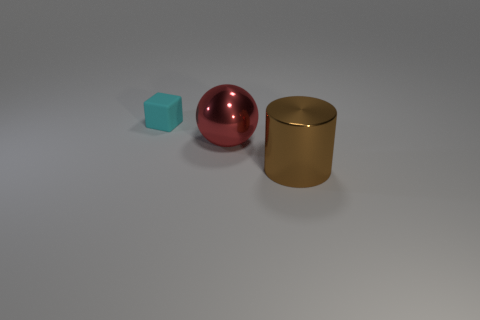Is there anything else that is the same size as the rubber cube?
Give a very brief answer. No. Is there anything else that is the same material as the tiny cyan block?
Make the answer very short. No. What number of big red things are there?
Provide a short and direct response. 1. What is the color of the thing that is right of the small rubber cube and behind the brown thing?
Your answer should be compact. Red. Are there any metal cylinders in front of the brown metal cylinder?
Your answer should be compact. No. What number of big metal things are behind the large metallic object on the left side of the brown object?
Your answer should be compact. 0. What size is the brown cylinder?
Provide a succinct answer. Large. Is the red sphere made of the same material as the large cylinder?
Ensure brevity in your answer.  Yes. How many cylinders are either tiny brown objects or big brown shiny objects?
Provide a short and direct response. 1. What color is the big metallic thing that is on the right side of the big metal thing that is on the left side of the brown shiny thing?
Give a very brief answer. Brown. 